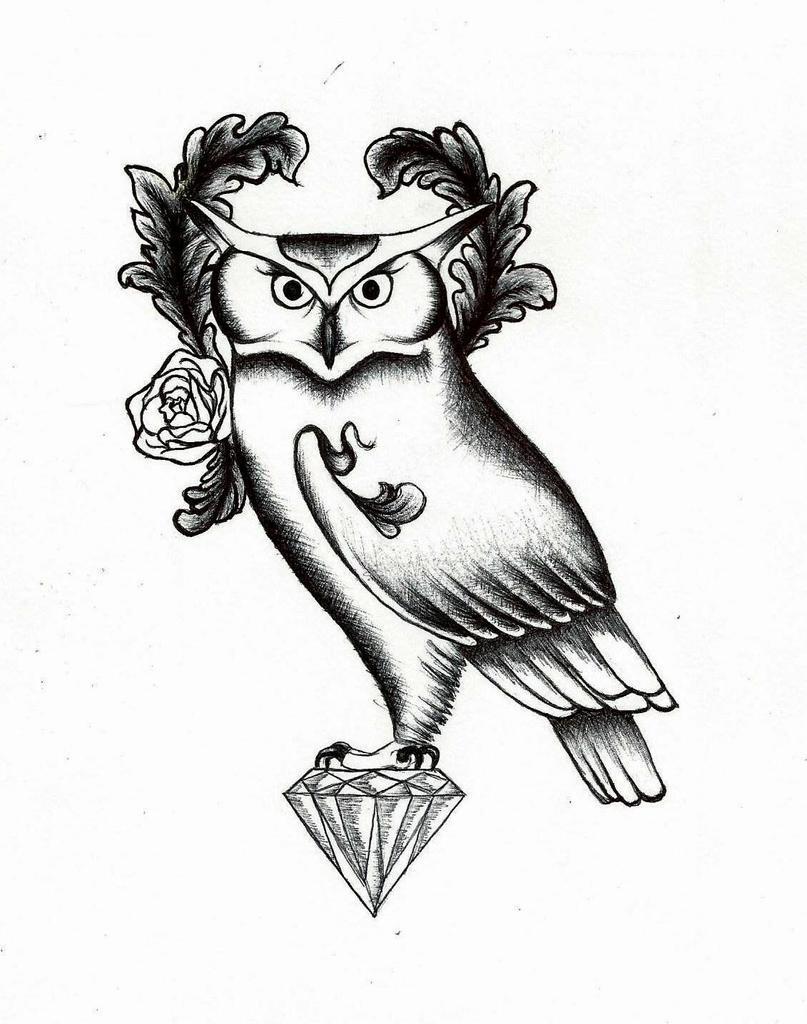How would you summarize this image in a sentence or two? In this image I can see depiction picture of an owl, a diamond and a flower. I can also see this image is black and white in colour. 